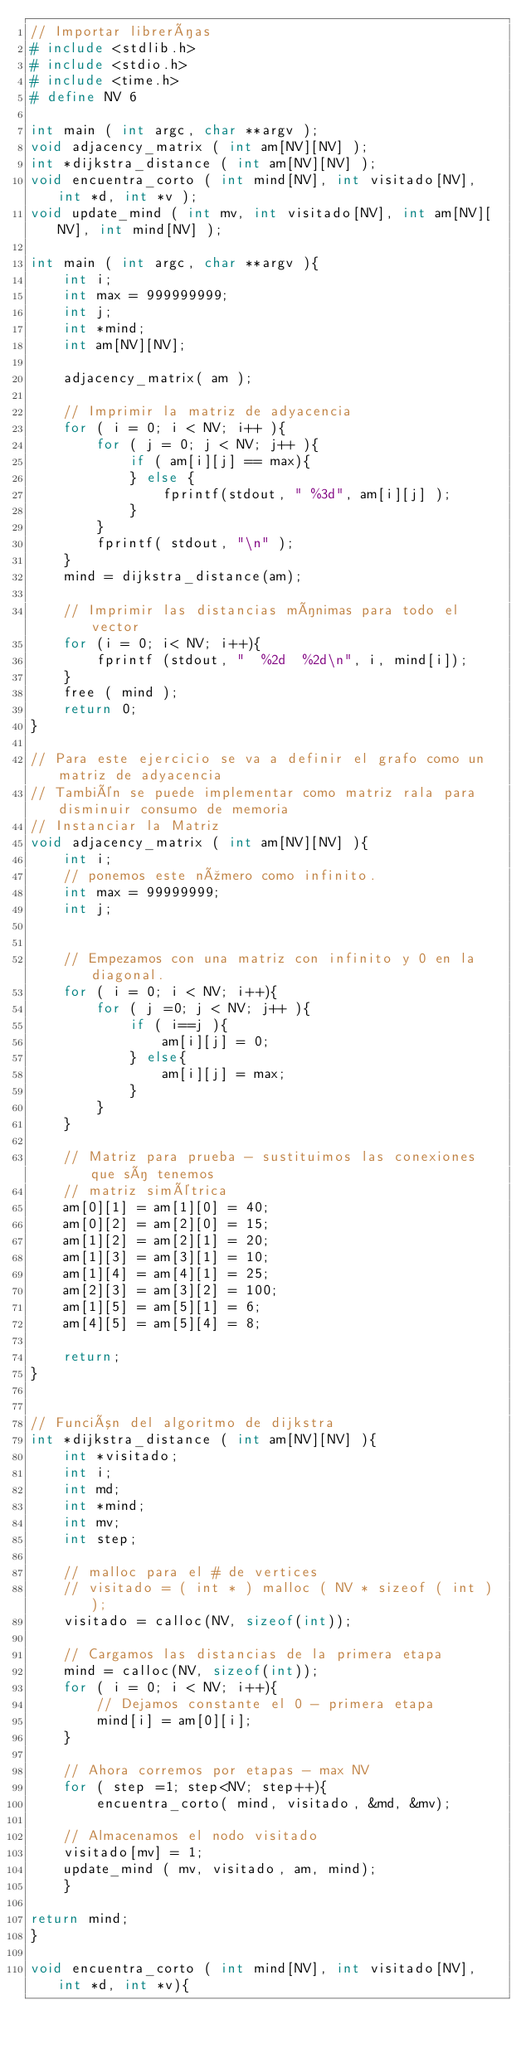Convert code to text. <code><loc_0><loc_0><loc_500><loc_500><_C_>// Importar librerías
# include <stdlib.h>
# include <stdio.h>
# include <time.h>
# define NV 6

int main ( int argc, char **argv );
void adjacency_matrix ( int am[NV][NV] );
int *dijkstra_distance ( int am[NV][NV] );
void encuentra_corto ( int mind[NV], int visitado[NV], int *d, int *v );
void update_mind ( int mv, int visitado[NV], int am[NV][NV], int mind[NV] );

int main ( int argc, char **argv ){
    int i;
    int max = 999999999;
    int j;
    int *mind;
    int am[NV][NV];

    adjacency_matrix( am );
    
    // Imprimir la matriz de adyacencia
    for ( i = 0; i < NV; i++ ){
        for ( j = 0; j < NV; j++ ){
            if ( am[i][j] == max){
            } else {
                fprintf(stdout, " %3d", am[i][j] );
            }
        }
        fprintf( stdout, "\n" );
    }
    mind = dijkstra_distance(am);

    // Imprimir las distancias mínimas para todo el vector
    for (i = 0; i< NV; i++){
        fprintf (stdout, "  %2d  %2d\n", i, mind[i]);
    }
    free ( mind );
    return 0;
}

// Para este ejercicio se va a definir el grafo como un matriz de adyacencia
// También se puede implementar como matriz rala para disminuir consumo de memoria
// Instanciar la Matriz
void adjacency_matrix ( int am[NV][NV] ){
    int i;
    // ponemos este número como infinito.
    int max = 99999999;
    int j;


    // Empezamos con una matriz con infinito y 0 en la diagonal.
    for ( i = 0; i < NV; i++){
        for ( j =0; j < NV; j++ ){
            if ( i==j ){
                am[i][j] = 0;
            } else{
                am[i][j] = max;
            }
        }
    }

    // Matriz para prueba - sustituimos las conexiones que sí tenemos
    // matriz simétrica
    am[0][1] = am[1][0] = 40;
    am[0][2] = am[2][0] = 15;
    am[1][2] = am[2][1] = 20;
    am[1][3] = am[3][1] = 10;
    am[1][4] = am[4][1] = 25;
    am[2][3] = am[3][2] = 100;
    am[1][5] = am[5][1] = 6;
    am[4][5] = am[5][4] = 8;

    return;
}


// Función del algoritmo de dijkstra
int *dijkstra_distance ( int am[NV][NV] ){
    int *visitado;
    int i;
    int md;
    int *mind;
    int mv;
    int step;

    // malloc para el # de vertices
    // visitado = ( int * ) malloc ( NV * sizeof ( int ) );
    visitado = calloc(NV, sizeof(int));

    // Cargamos las distancias de la primera etapa
    mind = calloc(NV, sizeof(int));
    for ( i = 0; i < NV; i++){
        // Dejamos constante el 0 - primera etapa
        mind[i] = am[0][i];
    }

    // Ahora corremos por etapas - max NV
    for ( step =1; step<NV; step++){
        encuentra_corto( mind, visitado, &md, &mv);

    // Almacenamos el nodo visitado
    visitado[mv] = 1;
    update_mind ( mv, visitado, am, mind);
    }

return mind;
}

void encuentra_corto ( int mind[NV], int visitado[NV], int *d, int *v){</code> 